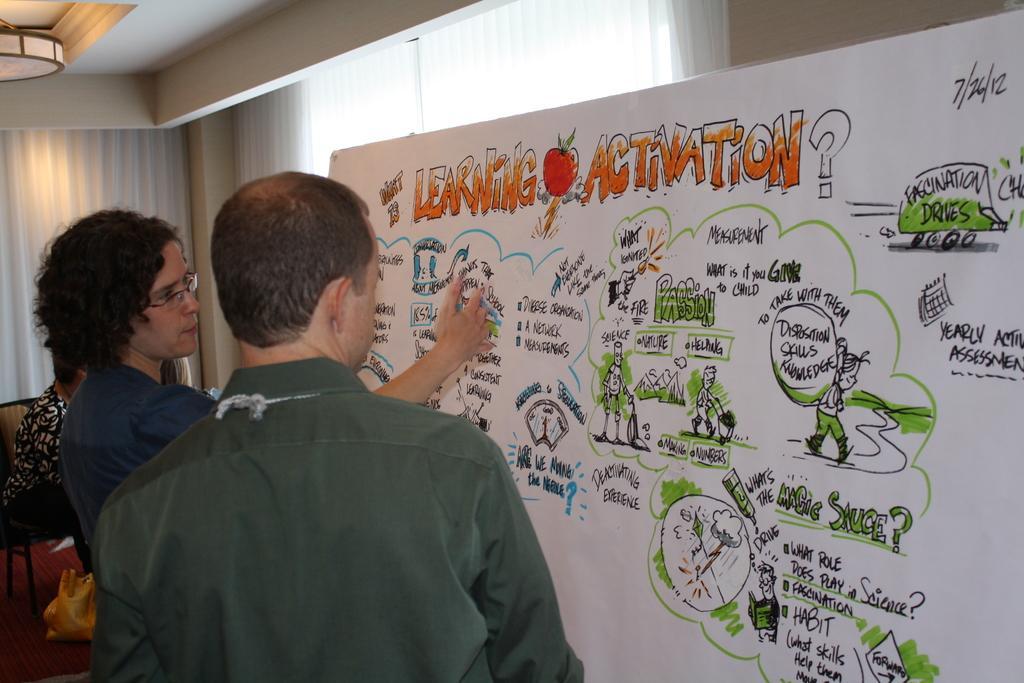How would you summarize this image in a sentence or two? In this picture we can see few people are in front of the board, on which we can see some diagrams, text, behind we can see a woman sitting on a couch. 